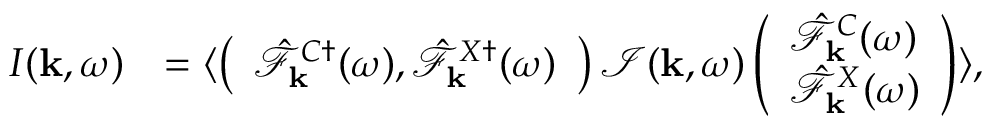<formula> <loc_0><loc_0><loc_500><loc_500>\begin{array} { r l } { I ( { k } , \omega ) } & { = \langle \left ( \begin{array} { l } { \hat { \mathcal { F } } _ { k } ^ { C \dagger } ( \omega ) , \hat { \mathcal { F } } _ { k } ^ { X \dagger } ( \omega ) } \end{array} \right ) \mathcal { I } ( { k } , \omega ) \left ( \begin{array} { l } { \hat { \mathcal { F } } _ { k } ^ { C } ( \omega ) } \\ { \hat { \mathcal { F } } _ { k } ^ { X } ( \omega ) } \end{array} \right ) \rangle , } \end{array}</formula> 